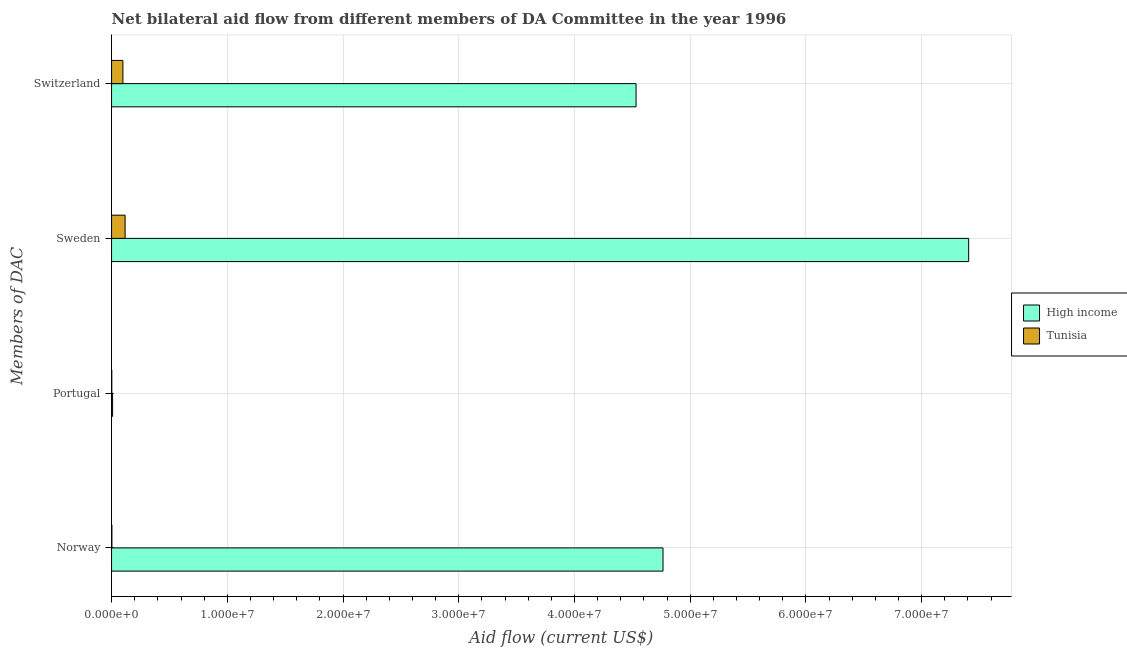How many groups of bars are there?
Provide a succinct answer. 4. Are the number of bars per tick equal to the number of legend labels?
Ensure brevity in your answer.  Yes. Are the number of bars on each tick of the Y-axis equal?
Your answer should be compact. Yes. How many bars are there on the 3rd tick from the top?
Your answer should be compact. 2. How many bars are there on the 1st tick from the bottom?
Your response must be concise. 2. What is the amount of aid given by portugal in Tunisia?
Provide a succinct answer. 2.00e+04. Across all countries, what is the maximum amount of aid given by switzerland?
Offer a very short reply. 4.53e+07. Across all countries, what is the minimum amount of aid given by portugal?
Your answer should be very brief. 2.00e+04. In which country was the amount of aid given by portugal maximum?
Your answer should be compact. High income. In which country was the amount of aid given by portugal minimum?
Your answer should be very brief. Tunisia. What is the total amount of aid given by sweden in the graph?
Your answer should be compact. 7.52e+07. What is the difference between the amount of aid given by norway in High income and that in Tunisia?
Make the answer very short. 4.76e+07. What is the difference between the amount of aid given by portugal in High income and the amount of aid given by norway in Tunisia?
Provide a short and direct response. 6.00e+04. What is the average amount of aid given by norway per country?
Provide a succinct answer. 2.38e+07. What is the difference between the amount of aid given by sweden and amount of aid given by portugal in High income?
Make the answer very short. 7.40e+07. In how many countries, is the amount of aid given by norway greater than 12000000 US$?
Offer a terse response. 1. What is the ratio of the amount of aid given by norway in Tunisia to that in High income?
Your response must be concise. 0. Is the amount of aid given by sweden in Tunisia less than that in High income?
Keep it short and to the point. Yes. What is the difference between the highest and the second highest amount of aid given by sweden?
Your response must be concise. 7.29e+07. What is the difference between the highest and the lowest amount of aid given by switzerland?
Ensure brevity in your answer.  4.43e+07. Is it the case that in every country, the sum of the amount of aid given by sweden and amount of aid given by norway is greater than the sum of amount of aid given by switzerland and amount of aid given by portugal?
Offer a terse response. No. What does the 1st bar from the top in Norway represents?
Provide a short and direct response. Tunisia. What does the 2nd bar from the bottom in Portugal represents?
Make the answer very short. Tunisia. Is it the case that in every country, the sum of the amount of aid given by norway and amount of aid given by portugal is greater than the amount of aid given by sweden?
Give a very brief answer. No. How many countries are there in the graph?
Give a very brief answer. 2. Does the graph contain any zero values?
Give a very brief answer. No. What is the title of the graph?
Your response must be concise. Net bilateral aid flow from different members of DA Committee in the year 1996. Does "Djibouti" appear as one of the legend labels in the graph?
Provide a succinct answer. No. What is the label or title of the X-axis?
Offer a very short reply. Aid flow (current US$). What is the label or title of the Y-axis?
Your answer should be compact. Members of DAC. What is the Aid flow (current US$) of High income in Norway?
Provide a short and direct response. 4.76e+07. What is the Aid flow (current US$) of Tunisia in Norway?
Offer a very short reply. 3.00e+04. What is the Aid flow (current US$) of High income in Sweden?
Your answer should be very brief. 7.41e+07. What is the Aid flow (current US$) of Tunisia in Sweden?
Your answer should be very brief. 1.17e+06. What is the Aid flow (current US$) in High income in Switzerland?
Your answer should be very brief. 4.53e+07. What is the Aid flow (current US$) in Tunisia in Switzerland?
Offer a very short reply. 9.80e+05. Across all Members of DAC, what is the maximum Aid flow (current US$) in High income?
Make the answer very short. 7.41e+07. Across all Members of DAC, what is the maximum Aid flow (current US$) in Tunisia?
Your response must be concise. 1.17e+06. Across all Members of DAC, what is the minimum Aid flow (current US$) of Tunisia?
Offer a very short reply. 2.00e+04. What is the total Aid flow (current US$) of High income in the graph?
Your answer should be very brief. 1.67e+08. What is the total Aid flow (current US$) of Tunisia in the graph?
Ensure brevity in your answer.  2.20e+06. What is the difference between the Aid flow (current US$) in High income in Norway and that in Portugal?
Offer a very short reply. 4.76e+07. What is the difference between the Aid flow (current US$) of Tunisia in Norway and that in Portugal?
Offer a terse response. 10000. What is the difference between the Aid flow (current US$) in High income in Norway and that in Sweden?
Ensure brevity in your answer.  -2.64e+07. What is the difference between the Aid flow (current US$) in Tunisia in Norway and that in Sweden?
Keep it short and to the point. -1.14e+06. What is the difference between the Aid flow (current US$) in High income in Norway and that in Switzerland?
Provide a short and direct response. 2.33e+06. What is the difference between the Aid flow (current US$) of Tunisia in Norway and that in Switzerland?
Your response must be concise. -9.50e+05. What is the difference between the Aid flow (current US$) in High income in Portugal and that in Sweden?
Provide a short and direct response. -7.40e+07. What is the difference between the Aid flow (current US$) of Tunisia in Portugal and that in Sweden?
Provide a succinct answer. -1.15e+06. What is the difference between the Aid flow (current US$) in High income in Portugal and that in Switzerland?
Keep it short and to the point. -4.52e+07. What is the difference between the Aid flow (current US$) of Tunisia in Portugal and that in Switzerland?
Offer a very short reply. -9.60e+05. What is the difference between the Aid flow (current US$) in High income in Sweden and that in Switzerland?
Your answer should be compact. 2.87e+07. What is the difference between the Aid flow (current US$) in Tunisia in Sweden and that in Switzerland?
Provide a short and direct response. 1.90e+05. What is the difference between the Aid flow (current US$) of High income in Norway and the Aid flow (current US$) of Tunisia in Portugal?
Make the answer very short. 4.76e+07. What is the difference between the Aid flow (current US$) in High income in Norway and the Aid flow (current US$) in Tunisia in Sweden?
Provide a succinct answer. 4.65e+07. What is the difference between the Aid flow (current US$) of High income in Norway and the Aid flow (current US$) of Tunisia in Switzerland?
Offer a very short reply. 4.67e+07. What is the difference between the Aid flow (current US$) of High income in Portugal and the Aid flow (current US$) of Tunisia in Sweden?
Give a very brief answer. -1.08e+06. What is the difference between the Aid flow (current US$) in High income in Portugal and the Aid flow (current US$) in Tunisia in Switzerland?
Offer a terse response. -8.90e+05. What is the difference between the Aid flow (current US$) in High income in Sweden and the Aid flow (current US$) in Tunisia in Switzerland?
Your response must be concise. 7.31e+07. What is the average Aid flow (current US$) in High income per Members of DAC?
Your answer should be compact. 4.18e+07. What is the average Aid flow (current US$) in Tunisia per Members of DAC?
Ensure brevity in your answer.  5.50e+05. What is the difference between the Aid flow (current US$) in High income and Aid flow (current US$) in Tunisia in Norway?
Ensure brevity in your answer.  4.76e+07. What is the difference between the Aid flow (current US$) in High income and Aid flow (current US$) in Tunisia in Sweden?
Your answer should be compact. 7.29e+07. What is the difference between the Aid flow (current US$) in High income and Aid flow (current US$) in Tunisia in Switzerland?
Give a very brief answer. 4.43e+07. What is the ratio of the Aid flow (current US$) in High income in Norway to that in Portugal?
Make the answer very short. 529.44. What is the ratio of the Aid flow (current US$) of High income in Norway to that in Sweden?
Keep it short and to the point. 0.64. What is the ratio of the Aid flow (current US$) in Tunisia in Norway to that in Sweden?
Give a very brief answer. 0.03. What is the ratio of the Aid flow (current US$) of High income in Norway to that in Switzerland?
Keep it short and to the point. 1.05. What is the ratio of the Aid flow (current US$) in Tunisia in Norway to that in Switzerland?
Your answer should be compact. 0.03. What is the ratio of the Aid flow (current US$) in High income in Portugal to that in Sweden?
Provide a succinct answer. 0. What is the ratio of the Aid flow (current US$) in Tunisia in Portugal to that in Sweden?
Provide a short and direct response. 0.02. What is the ratio of the Aid flow (current US$) of High income in Portugal to that in Switzerland?
Provide a short and direct response. 0. What is the ratio of the Aid flow (current US$) of Tunisia in Portugal to that in Switzerland?
Provide a short and direct response. 0.02. What is the ratio of the Aid flow (current US$) in High income in Sweden to that in Switzerland?
Your answer should be compact. 1.63. What is the ratio of the Aid flow (current US$) of Tunisia in Sweden to that in Switzerland?
Ensure brevity in your answer.  1.19. What is the difference between the highest and the second highest Aid flow (current US$) in High income?
Your answer should be very brief. 2.64e+07. What is the difference between the highest and the lowest Aid flow (current US$) of High income?
Ensure brevity in your answer.  7.40e+07. What is the difference between the highest and the lowest Aid flow (current US$) in Tunisia?
Give a very brief answer. 1.15e+06. 